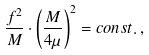Convert formula to latex. <formula><loc_0><loc_0><loc_500><loc_500>\frac { f ^ { 2 } } { M } \cdot \left ( \frac { M } { 4 \mu } \right ) ^ { 2 } = c o n s t . \, ,</formula> 